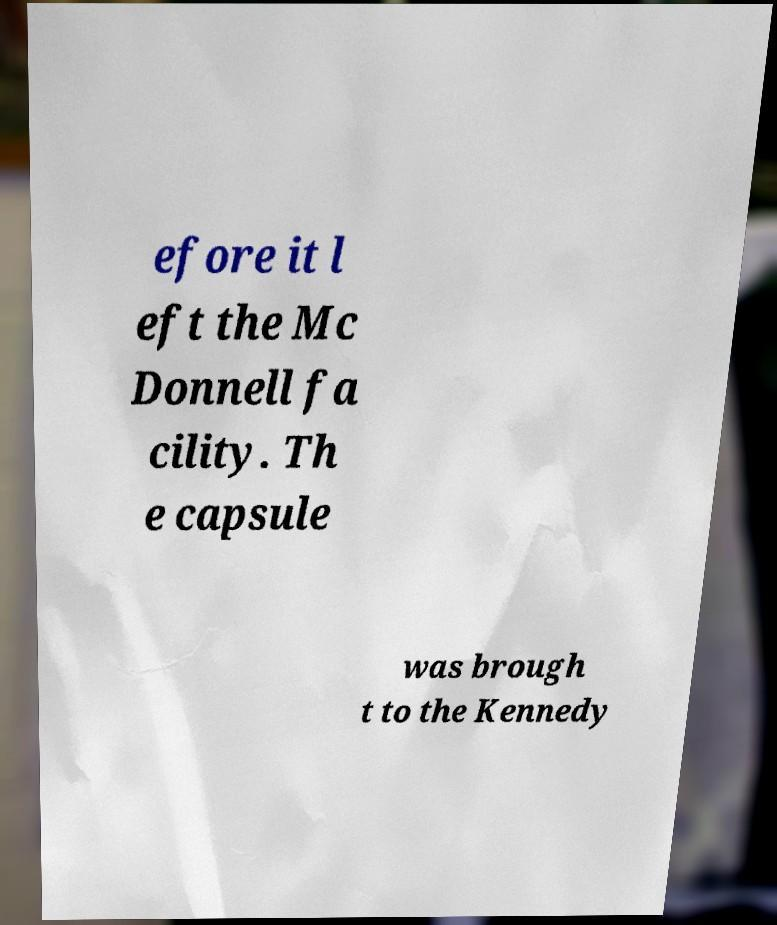What messages or text are displayed in this image? I need them in a readable, typed format. efore it l eft the Mc Donnell fa cility. Th e capsule was brough t to the Kennedy 